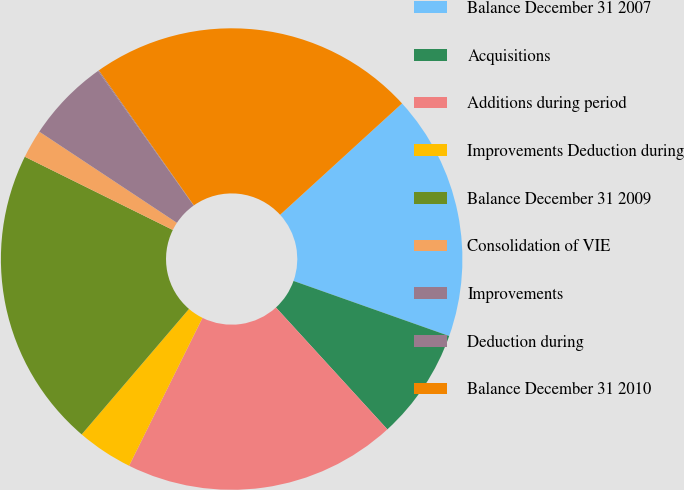<chart> <loc_0><loc_0><loc_500><loc_500><pie_chart><fcel>Balance December 31 2007<fcel>Acquisitions<fcel>Additions during period<fcel>Improvements Deduction during<fcel>Balance December 31 2009<fcel>Consolidation of VIE<fcel>Improvements<fcel>Deduction during<fcel>Balance December 31 2010<nl><fcel>17.19%<fcel>7.8%<fcel>19.12%<fcel>3.93%<fcel>21.05%<fcel>2.0%<fcel>5.86%<fcel>0.07%<fcel>22.98%<nl></chart> 